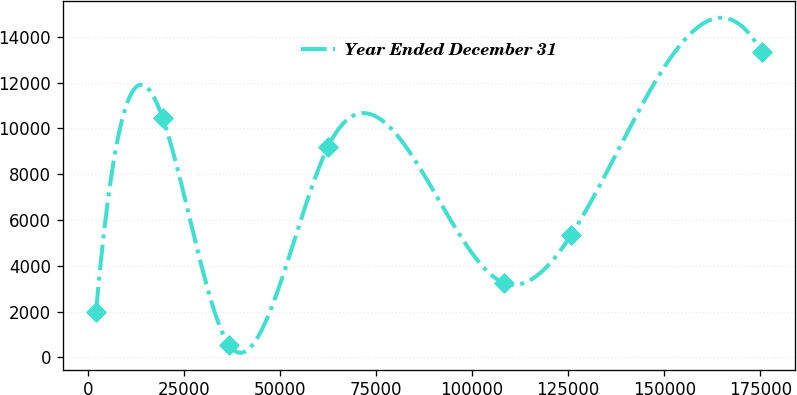Convert chart. <chart><loc_0><loc_0><loc_500><loc_500><line_chart><ecel><fcel>Year Ended December 31<nl><fcel>2162.87<fcel>1960.68<nl><fcel>19481.2<fcel>10464.4<nl><fcel>36799.6<fcel>535.17<nl><fcel>62503.6<fcel>9185.05<nl><fcel>108386<fcel>3246.49<nl><fcel>125705<fcel>5322.04<nl><fcel>175346<fcel>13328.8<nl></chart> 